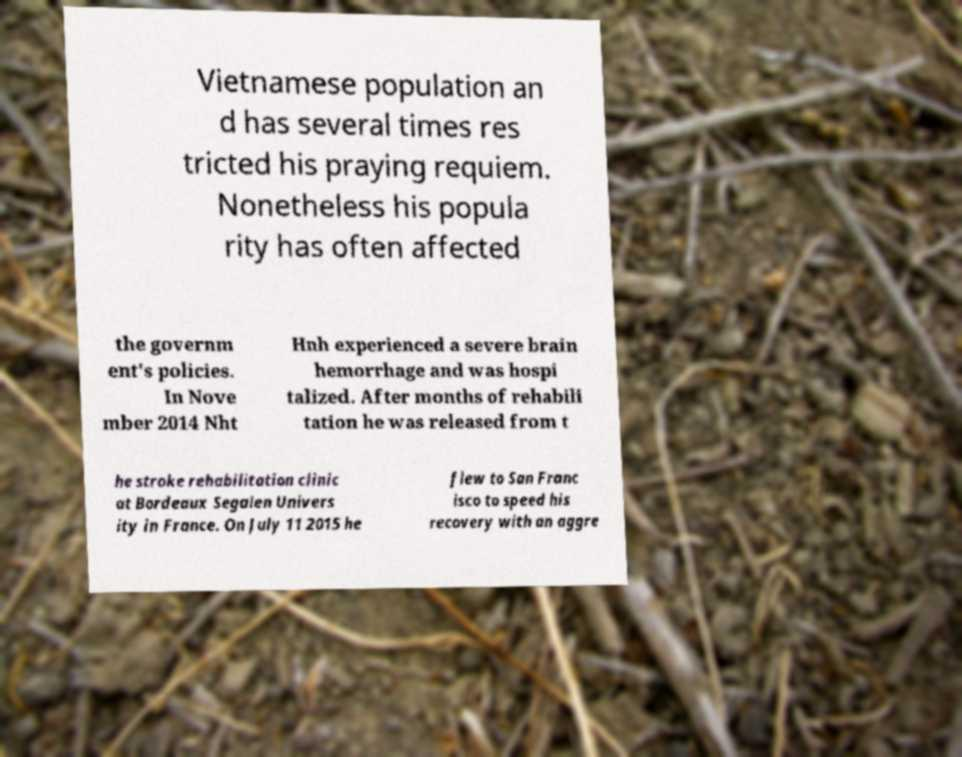Can you accurately transcribe the text from the provided image for me? Vietnamese population an d has several times res tricted his praying requiem. Nonetheless his popula rity has often affected the governm ent's policies. In Nove mber 2014 Nht Hnh experienced a severe brain hemorrhage and was hospi talized. After months of rehabili tation he was released from t he stroke rehabilitation clinic at Bordeaux Segalen Univers ity in France. On July 11 2015 he flew to San Franc isco to speed his recovery with an aggre 